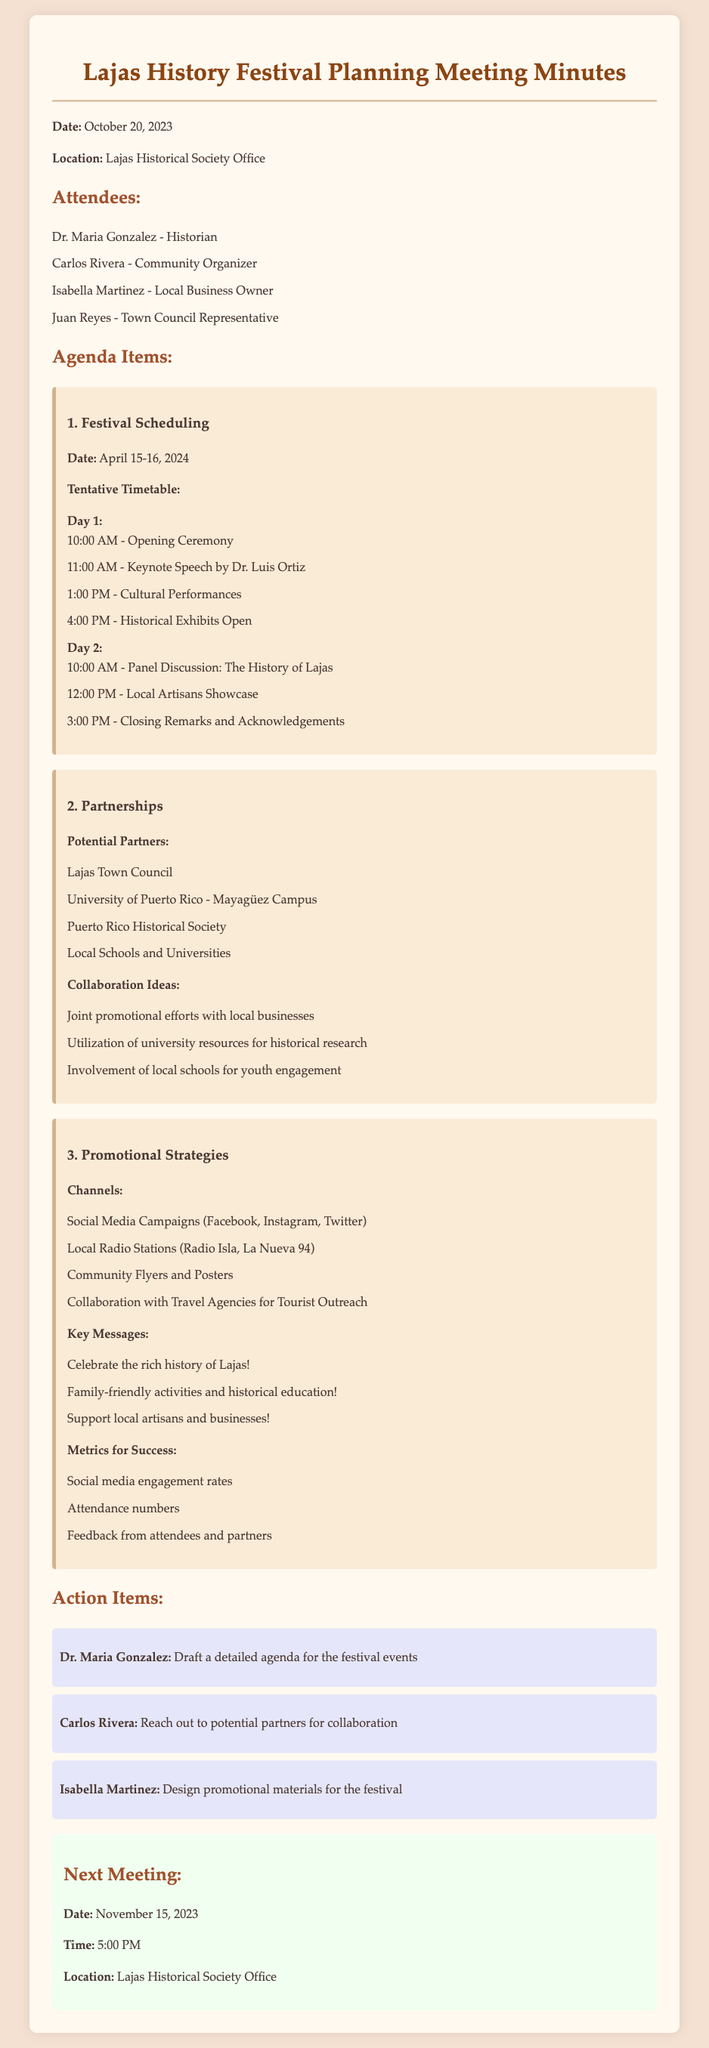What are the dates of the festival? The festival is scheduled for April 15-16, 2024.
Answer: April 15-16, 2024 Who is responsible for drafting the detailed agenda? Dr. Maria Gonzalez is tasked with drafting a detailed agenda for the festival events.
Answer: Dr. Maria Gonzalez What time does the opening ceremony start? The opening ceremony is scheduled to begin at 10:00 AM on Day 1.
Answer: 10:00 AM Name one potential partner for the festival. One of the potential partners mentioned in the meeting is the Lajas Town Council.
Answer: Lajas Town Council What is one channel for promotional strategies? One channel listed for promotional strategies is Social Media Campaigns.
Answer: Social Media Campaigns What are the key messages for the festival? Key messages include "Celebrate the rich history of Lajas!"
Answer: "Celebrate the rich history of Lajas!" What is the location of the next meeting? The next meeting will take place at the Lajas Historical Society Office.
Answer: Lajas Historical Society Office How many attendees were present at the meeting? There were four attendees present at the meeting.
Answer: Four What time is the next meeting scheduled for? The next meeting is scheduled for 5:00 PM.
Answer: 5:00 PM 